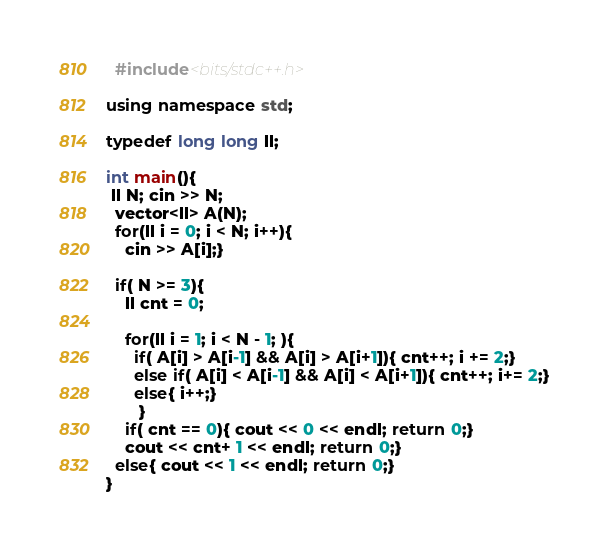<code> <loc_0><loc_0><loc_500><loc_500><_C++_>  #include<bits/stdc++.h>

using namespace std;

typedef long long ll;

int main(){
 ll N; cin >> N;
  vector<ll> A(N);
  for(ll i = 0; i < N; i++){
    cin >> A[i];}
  
  if( N >= 3){
    ll cnt = 0;
    
    for(ll i = 1; i < N - 1; ){
      if( A[i] > A[i-1] && A[i] > A[i+1]){ cnt++; i += 2;}
      else if( A[i] < A[i-1] && A[i] < A[i+1]){ cnt++; i+= 2;}
      else{ i++;}
       }
    if( cnt == 0){ cout << 0 << endl; return 0;}
    cout << cnt+ 1 << endl; return 0;}
  else{ cout << 1 << endl; return 0;}
}
</code> 